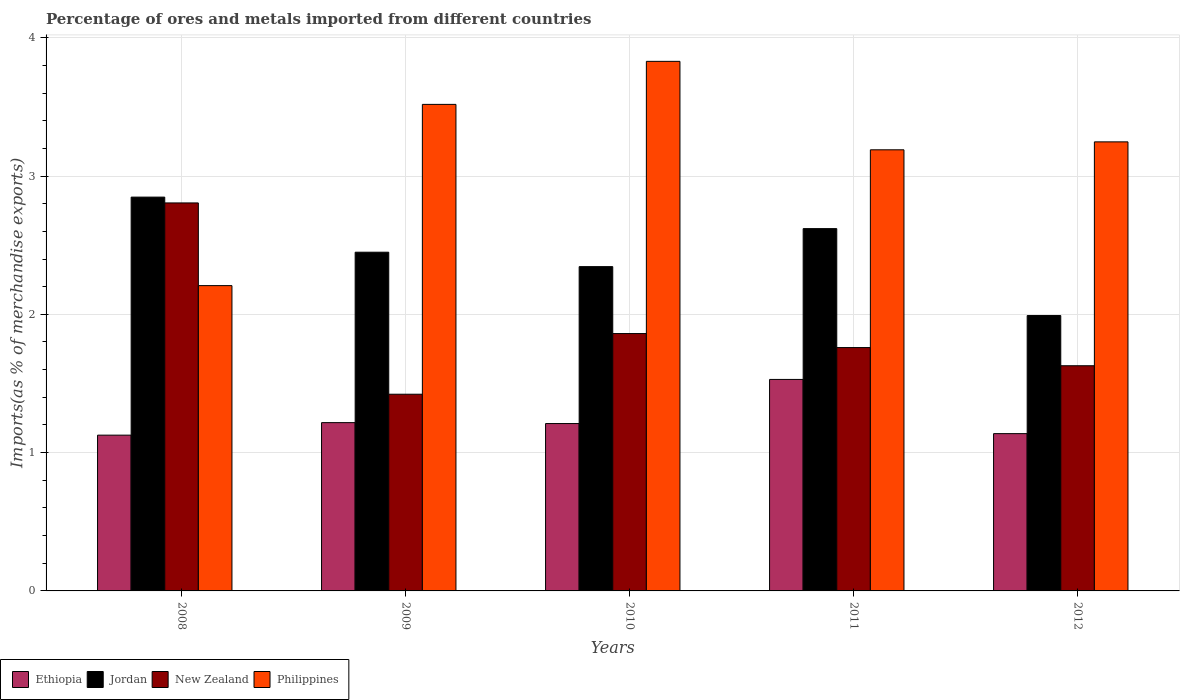How many groups of bars are there?
Ensure brevity in your answer.  5. Are the number of bars on each tick of the X-axis equal?
Your answer should be very brief. Yes. What is the percentage of imports to different countries in Ethiopia in 2012?
Ensure brevity in your answer.  1.14. Across all years, what is the maximum percentage of imports to different countries in Ethiopia?
Make the answer very short. 1.53. Across all years, what is the minimum percentage of imports to different countries in Jordan?
Offer a very short reply. 1.99. In which year was the percentage of imports to different countries in Philippines maximum?
Provide a succinct answer. 2010. In which year was the percentage of imports to different countries in Jordan minimum?
Offer a very short reply. 2012. What is the total percentage of imports to different countries in Philippines in the graph?
Provide a short and direct response. 15.99. What is the difference between the percentage of imports to different countries in Jordan in 2011 and that in 2012?
Offer a very short reply. 0.63. What is the difference between the percentage of imports to different countries in Jordan in 2011 and the percentage of imports to different countries in Philippines in 2010?
Keep it short and to the point. -1.21. What is the average percentage of imports to different countries in Ethiopia per year?
Your answer should be very brief. 1.24. In the year 2010, what is the difference between the percentage of imports to different countries in Jordan and percentage of imports to different countries in Philippines?
Ensure brevity in your answer.  -1.48. In how many years, is the percentage of imports to different countries in New Zealand greater than 3 %?
Ensure brevity in your answer.  0. What is the ratio of the percentage of imports to different countries in New Zealand in 2011 to that in 2012?
Ensure brevity in your answer.  1.08. What is the difference between the highest and the second highest percentage of imports to different countries in New Zealand?
Provide a succinct answer. 0.94. What is the difference between the highest and the lowest percentage of imports to different countries in New Zealand?
Your response must be concise. 1.38. In how many years, is the percentage of imports to different countries in Philippines greater than the average percentage of imports to different countries in Philippines taken over all years?
Keep it short and to the point. 3. Is it the case that in every year, the sum of the percentage of imports to different countries in Jordan and percentage of imports to different countries in Ethiopia is greater than the sum of percentage of imports to different countries in Philippines and percentage of imports to different countries in New Zealand?
Your answer should be compact. No. What does the 2nd bar from the left in 2010 represents?
Keep it short and to the point. Jordan. What does the 1st bar from the right in 2009 represents?
Provide a short and direct response. Philippines. How many bars are there?
Your answer should be very brief. 20. Are all the bars in the graph horizontal?
Your response must be concise. No. How many years are there in the graph?
Provide a succinct answer. 5. Does the graph contain any zero values?
Make the answer very short. No. Where does the legend appear in the graph?
Your answer should be very brief. Bottom left. How many legend labels are there?
Your answer should be compact. 4. How are the legend labels stacked?
Offer a terse response. Horizontal. What is the title of the graph?
Offer a terse response. Percentage of ores and metals imported from different countries. Does "Suriname" appear as one of the legend labels in the graph?
Provide a succinct answer. No. What is the label or title of the Y-axis?
Your response must be concise. Imports(as % of merchandise exports). What is the Imports(as % of merchandise exports) of Ethiopia in 2008?
Make the answer very short. 1.13. What is the Imports(as % of merchandise exports) of Jordan in 2008?
Ensure brevity in your answer.  2.85. What is the Imports(as % of merchandise exports) in New Zealand in 2008?
Your answer should be very brief. 2.81. What is the Imports(as % of merchandise exports) in Philippines in 2008?
Your response must be concise. 2.21. What is the Imports(as % of merchandise exports) in Ethiopia in 2009?
Give a very brief answer. 1.22. What is the Imports(as % of merchandise exports) of Jordan in 2009?
Your answer should be compact. 2.45. What is the Imports(as % of merchandise exports) of New Zealand in 2009?
Provide a short and direct response. 1.42. What is the Imports(as % of merchandise exports) of Philippines in 2009?
Give a very brief answer. 3.52. What is the Imports(as % of merchandise exports) in Ethiopia in 2010?
Make the answer very short. 1.21. What is the Imports(as % of merchandise exports) of Jordan in 2010?
Keep it short and to the point. 2.34. What is the Imports(as % of merchandise exports) of New Zealand in 2010?
Ensure brevity in your answer.  1.86. What is the Imports(as % of merchandise exports) of Philippines in 2010?
Your response must be concise. 3.83. What is the Imports(as % of merchandise exports) in Ethiopia in 2011?
Provide a succinct answer. 1.53. What is the Imports(as % of merchandise exports) in Jordan in 2011?
Keep it short and to the point. 2.62. What is the Imports(as % of merchandise exports) of New Zealand in 2011?
Offer a very short reply. 1.76. What is the Imports(as % of merchandise exports) in Philippines in 2011?
Provide a succinct answer. 3.19. What is the Imports(as % of merchandise exports) of Ethiopia in 2012?
Your answer should be compact. 1.14. What is the Imports(as % of merchandise exports) in Jordan in 2012?
Your response must be concise. 1.99. What is the Imports(as % of merchandise exports) of New Zealand in 2012?
Give a very brief answer. 1.63. What is the Imports(as % of merchandise exports) of Philippines in 2012?
Offer a terse response. 3.25. Across all years, what is the maximum Imports(as % of merchandise exports) of Ethiopia?
Offer a terse response. 1.53. Across all years, what is the maximum Imports(as % of merchandise exports) of Jordan?
Your answer should be compact. 2.85. Across all years, what is the maximum Imports(as % of merchandise exports) of New Zealand?
Your answer should be very brief. 2.81. Across all years, what is the maximum Imports(as % of merchandise exports) of Philippines?
Ensure brevity in your answer.  3.83. Across all years, what is the minimum Imports(as % of merchandise exports) in Ethiopia?
Give a very brief answer. 1.13. Across all years, what is the minimum Imports(as % of merchandise exports) in Jordan?
Your answer should be very brief. 1.99. Across all years, what is the minimum Imports(as % of merchandise exports) in New Zealand?
Give a very brief answer. 1.42. Across all years, what is the minimum Imports(as % of merchandise exports) in Philippines?
Ensure brevity in your answer.  2.21. What is the total Imports(as % of merchandise exports) in Ethiopia in the graph?
Provide a short and direct response. 6.22. What is the total Imports(as % of merchandise exports) in Jordan in the graph?
Offer a terse response. 12.25. What is the total Imports(as % of merchandise exports) in New Zealand in the graph?
Offer a terse response. 9.48. What is the total Imports(as % of merchandise exports) in Philippines in the graph?
Your answer should be compact. 15.99. What is the difference between the Imports(as % of merchandise exports) of Ethiopia in 2008 and that in 2009?
Keep it short and to the point. -0.09. What is the difference between the Imports(as % of merchandise exports) in Jordan in 2008 and that in 2009?
Your response must be concise. 0.4. What is the difference between the Imports(as % of merchandise exports) in New Zealand in 2008 and that in 2009?
Provide a short and direct response. 1.38. What is the difference between the Imports(as % of merchandise exports) of Philippines in 2008 and that in 2009?
Your answer should be very brief. -1.31. What is the difference between the Imports(as % of merchandise exports) in Ethiopia in 2008 and that in 2010?
Your response must be concise. -0.08. What is the difference between the Imports(as % of merchandise exports) of Jordan in 2008 and that in 2010?
Ensure brevity in your answer.  0.5. What is the difference between the Imports(as % of merchandise exports) of New Zealand in 2008 and that in 2010?
Keep it short and to the point. 0.94. What is the difference between the Imports(as % of merchandise exports) of Philippines in 2008 and that in 2010?
Provide a short and direct response. -1.62. What is the difference between the Imports(as % of merchandise exports) of Ethiopia in 2008 and that in 2011?
Provide a short and direct response. -0.4. What is the difference between the Imports(as % of merchandise exports) of Jordan in 2008 and that in 2011?
Your response must be concise. 0.23. What is the difference between the Imports(as % of merchandise exports) of New Zealand in 2008 and that in 2011?
Offer a terse response. 1.05. What is the difference between the Imports(as % of merchandise exports) of Philippines in 2008 and that in 2011?
Make the answer very short. -0.98. What is the difference between the Imports(as % of merchandise exports) in Ethiopia in 2008 and that in 2012?
Your answer should be compact. -0.01. What is the difference between the Imports(as % of merchandise exports) of Jordan in 2008 and that in 2012?
Your answer should be very brief. 0.86. What is the difference between the Imports(as % of merchandise exports) in New Zealand in 2008 and that in 2012?
Your response must be concise. 1.18. What is the difference between the Imports(as % of merchandise exports) of Philippines in 2008 and that in 2012?
Your answer should be compact. -1.04. What is the difference between the Imports(as % of merchandise exports) in Ethiopia in 2009 and that in 2010?
Ensure brevity in your answer.  0.01. What is the difference between the Imports(as % of merchandise exports) of Jordan in 2009 and that in 2010?
Ensure brevity in your answer.  0.1. What is the difference between the Imports(as % of merchandise exports) in New Zealand in 2009 and that in 2010?
Provide a succinct answer. -0.44. What is the difference between the Imports(as % of merchandise exports) of Philippines in 2009 and that in 2010?
Your answer should be very brief. -0.31. What is the difference between the Imports(as % of merchandise exports) of Ethiopia in 2009 and that in 2011?
Your answer should be compact. -0.31. What is the difference between the Imports(as % of merchandise exports) in Jordan in 2009 and that in 2011?
Your answer should be compact. -0.17. What is the difference between the Imports(as % of merchandise exports) in New Zealand in 2009 and that in 2011?
Your answer should be very brief. -0.34. What is the difference between the Imports(as % of merchandise exports) of Philippines in 2009 and that in 2011?
Provide a succinct answer. 0.33. What is the difference between the Imports(as % of merchandise exports) in Ethiopia in 2009 and that in 2012?
Ensure brevity in your answer.  0.08. What is the difference between the Imports(as % of merchandise exports) of Jordan in 2009 and that in 2012?
Make the answer very short. 0.46. What is the difference between the Imports(as % of merchandise exports) in New Zealand in 2009 and that in 2012?
Ensure brevity in your answer.  -0.21. What is the difference between the Imports(as % of merchandise exports) in Philippines in 2009 and that in 2012?
Ensure brevity in your answer.  0.27. What is the difference between the Imports(as % of merchandise exports) of Ethiopia in 2010 and that in 2011?
Your answer should be compact. -0.32. What is the difference between the Imports(as % of merchandise exports) in Jordan in 2010 and that in 2011?
Provide a succinct answer. -0.27. What is the difference between the Imports(as % of merchandise exports) of New Zealand in 2010 and that in 2011?
Your answer should be compact. 0.1. What is the difference between the Imports(as % of merchandise exports) in Philippines in 2010 and that in 2011?
Provide a short and direct response. 0.64. What is the difference between the Imports(as % of merchandise exports) in Ethiopia in 2010 and that in 2012?
Give a very brief answer. 0.07. What is the difference between the Imports(as % of merchandise exports) in Jordan in 2010 and that in 2012?
Provide a succinct answer. 0.35. What is the difference between the Imports(as % of merchandise exports) in New Zealand in 2010 and that in 2012?
Your answer should be compact. 0.23. What is the difference between the Imports(as % of merchandise exports) in Philippines in 2010 and that in 2012?
Provide a short and direct response. 0.58. What is the difference between the Imports(as % of merchandise exports) of Ethiopia in 2011 and that in 2012?
Provide a short and direct response. 0.39. What is the difference between the Imports(as % of merchandise exports) in Jordan in 2011 and that in 2012?
Offer a very short reply. 0.63. What is the difference between the Imports(as % of merchandise exports) in New Zealand in 2011 and that in 2012?
Give a very brief answer. 0.13. What is the difference between the Imports(as % of merchandise exports) of Philippines in 2011 and that in 2012?
Provide a succinct answer. -0.06. What is the difference between the Imports(as % of merchandise exports) of Ethiopia in 2008 and the Imports(as % of merchandise exports) of Jordan in 2009?
Provide a succinct answer. -1.32. What is the difference between the Imports(as % of merchandise exports) of Ethiopia in 2008 and the Imports(as % of merchandise exports) of New Zealand in 2009?
Your response must be concise. -0.3. What is the difference between the Imports(as % of merchandise exports) of Ethiopia in 2008 and the Imports(as % of merchandise exports) of Philippines in 2009?
Offer a very short reply. -2.39. What is the difference between the Imports(as % of merchandise exports) of Jordan in 2008 and the Imports(as % of merchandise exports) of New Zealand in 2009?
Provide a succinct answer. 1.43. What is the difference between the Imports(as % of merchandise exports) of Jordan in 2008 and the Imports(as % of merchandise exports) of Philippines in 2009?
Provide a succinct answer. -0.67. What is the difference between the Imports(as % of merchandise exports) of New Zealand in 2008 and the Imports(as % of merchandise exports) of Philippines in 2009?
Offer a very short reply. -0.71. What is the difference between the Imports(as % of merchandise exports) of Ethiopia in 2008 and the Imports(as % of merchandise exports) of Jordan in 2010?
Give a very brief answer. -1.22. What is the difference between the Imports(as % of merchandise exports) in Ethiopia in 2008 and the Imports(as % of merchandise exports) in New Zealand in 2010?
Give a very brief answer. -0.73. What is the difference between the Imports(as % of merchandise exports) of Ethiopia in 2008 and the Imports(as % of merchandise exports) of Philippines in 2010?
Your answer should be very brief. -2.7. What is the difference between the Imports(as % of merchandise exports) of Jordan in 2008 and the Imports(as % of merchandise exports) of New Zealand in 2010?
Keep it short and to the point. 0.99. What is the difference between the Imports(as % of merchandise exports) of Jordan in 2008 and the Imports(as % of merchandise exports) of Philippines in 2010?
Your answer should be compact. -0.98. What is the difference between the Imports(as % of merchandise exports) of New Zealand in 2008 and the Imports(as % of merchandise exports) of Philippines in 2010?
Ensure brevity in your answer.  -1.02. What is the difference between the Imports(as % of merchandise exports) in Ethiopia in 2008 and the Imports(as % of merchandise exports) in Jordan in 2011?
Give a very brief answer. -1.49. What is the difference between the Imports(as % of merchandise exports) of Ethiopia in 2008 and the Imports(as % of merchandise exports) of New Zealand in 2011?
Make the answer very short. -0.63. What is the difference between the Imports(as % of merchandise exports) in Ethiopia in 2008 and the Imports(as % of merchandise exports) in Philippines in 2011?
Give a very brief answer. -2.06. What is the difference between the Imports(as % of merchandise exports) in Jordan in 2008 and the Imports(as % of merchandise exports) in New Zealand in 2011?
Offer a very short reply. 1.09. What is the difference between the Imports(as % of merchandise exports) in Jordan in 2008 and the Imports(as % of merchandise exports) in Philippines in 2011?
Keep it short and to the point. -0.34. What is the difference between the Imports(as % of merchandise exports) of New Zealand in 2008 and the Imports(as % of merchandise exports) of Philippines in 2011?
Give a very brief answer. -0.38. What is the difference between the Imports(as % of merchandise exports) in Ethiopia in 2008 and the Imports(as % of merchandise exports) in Jordan in 2012?
Your answer should be very brief. -0.86. What is the difference between the Imports(as % of merchandise exports) in Ethiopia in 2008 and the Imports(as % of merchandise exports) in New Zealand in 2012?
Give a very brief answer. -0.5. What is the difference between the Imports(as % of merchandise exports) of Ethiopia in 2008 and the Imports(as % of merchandise exports) of Philippines in 2012?
Your response must be concise. -2.12. What is the difference between the Imports(as % of merchandise exports) of Jordan in 2008 and the Imports(as % of merchandise exports) of New Zealand in 2012?
Ensure brevity in your answer.  1.22. What is the difference between the Imports(as % of merchandise exports) in Jordan in 2008 and the Imports(as % of merchandise exports) in Philippines in 2012?
Provide a short and direct response. -0.4. What is the difference between the Imports(as % of merchandise exports) of New Zealand in 2008 and the Imports(as % of merchandise exports) of Philippines in 2012?
Provide a short and direct response. -0.44. What is the difference between the Imports(as % of merchandise exports) of Ethiopia in 2009 and the Imports(as % of merchandise exports) of Jordan in 2010?
Make the answer very short. -1.13. What is the difference between the Imports(as % of merchandise exports) in Ethiopia in 2009 and the Imports(as % of merchandise exports) in New Zealand in 2010?
Provide a short and direct response. -0.64. What is the difference between the Imports(as % of merchandise exports) in Ethiopia in 2009 and the Imports(as % of merchandise exports) in Philippines in 2010?
Offer a very short reply. -2.61. What is the difference between the Imports(as % of merchandise exports) in Jordan in 2009 and the Imports(as % of merchandise exports) in New Zealand in 2010?
Your answer should be very brief. 0.59. What is the difference between the Imports(as % of merchandise exports) in Jordan in 2009 and the Imports(as % of merchandise exports) in Philippines in 2010?
Make the answer very short. -1.38. What is the difference between the Imports(as % of merchandise exports) of New Zealand in 2009 and the Imports(as % of merchandise exports) of Philippines in 2010?
Provide a short and direct response. -2.41. What is the difference between the Imports(as % of merchandise exports) in Ethiopia in 2009 and the Imports(as % of merchandise exports) in Jordan in 2011?
Make the answer very short. -1.4. What is the difference between the Imports(as % of merchandise exports) of Ethiopia in 2009 and the Imports(as % of merchandise exports) of New Zealand in 2011?
Give a very brief answer. -0.54. What is the difference between the Imports(as % of merchandise exports) in Ethiopia in 2009 and the Imports(as % of merchandise exports) in Philippines in 2011?
Keep it short and to the point. -1.97. What is the difference between the Imports(as % of merchandise exports) in Jordan in 2009 and the Imports(as % of merchandise exports) in New Zealand in 2011?
Ensure brevity in your answer.  0.69. What is the difference between the Imports(as % of merchandise exports) in Jordan in 2009 and the Imports(as % of merchandise exports) in Philippines in 2011?
Your answer should be compact. -0.74. What is the difference between the Imports(as % of merchandise exports) in New Zealand in 2009 and the Imports(as % of merchandise exports) in Philippines in 2011?
Your response must be concise. -1.77. What is the difference between the Imports(as % of merchandise exports) of Ethiopia in 2009 and the Imports(as % of merchandise exports) of Jordan in 2012?
Keep it short and to the point. -0.77. What is the difference between the Imports(as % of merchandise exports) in Ethiopia in 2009 and the Imports(as % of merchandise exports) in New Zealand in 2012?
Offer a terse response. -0.41. What is the difference between the Imports(as % of merchandise exports) in Ethiopia in 2009 and the Imports(as % of merchandise exports) in Philippines in 2012?
Your response must be concise. -2.03. What is the difference between the Imports(as % of merchandise exports) in Jordan in 2009 and the Imports(as % of merchandise exports) in New Zealand in 2012?
Give a very brief answer. 0.82. What is the difference between the Imports(as % of merchandise exports) of Jordan in 2009 and the Imports(as % of merchandise exports) of Philippines in 2012?
Make the answer very short. -0.8. What is the difference between the Imports(as % of merchandise exports) of New Zealand in 2009 and the Imports(as % of merchandise exports) of Philippines in 2012?
Offer a terse response. -1.82. What is the difference between the Imports(as % of merchandise exports) in Ethiopia in 2010 and the Imports(as % of merchandise exports) in Jordan in 2011?
Provide a succinct answer. -1.41. What is the difference between the Imports(as % of merchandise exports) of Ethiopia in 2010 and the Imports(as % of merchandise exports) of New Zealand in 2011?
Make the answer very short. -0.55. What is the difference between the Imports(as % of merchandise exports) of Ethiopia in 2010 and the Imports(as % of merchandise exports) of Philippines in 2011?
Ensure brevity in your answer.  -1.98. What is the difference between the Imports(as % of merchandise exports) of Jordan in 2010 and the Imports(as % of merchandise exports) of New Zealand in 2011?
Your response must be concise. 0.59. What is the difference between the Imports(as % of merchandise exports) of Jordan in 2010 and the Imports(as % of merchandise exports) of Philippines in 2011?
Give a very brief answer. -0.84. What is the difference between the Imports(as % of merchandise exports) of New Zealand in 2010 and the Imports(as % of merchandise exports) of Philippines in 2011?
Make the answer very short. -1.33. What is the difference between the Imports(as % of merchandise exports) in Ethiopia in 2010 and the Imports(as % of merchandise exports) in Jordan in 2012?
Provide a succinct answer. -0.78. What is the difference between the Imports(as % of merchandise exports) in Ethiopia in 2010 and the Imports(as % of merchandise exports) in New Zealand in 2012?
Provide a short and direct response. -0.42. What is the difference between the Imports(as % of merchandise exports) in Ethiopia in 2010 and the Imports(as % of merchandise exports) in Philippines in 2012?
Make the answer very short. -2.04. What is the difference between the Imports(as % of merchandise exports) in Jordan in 2010 and the Imports(as % of merchandise exports) in New Zealand in 2012?
Keep it short and to the point. 0.72. What is the difference between the Imports(as % of merchandise exports) of Jordan in 2010 and the Imports(as % of merchandise exports) of Philippines in 2012?
Offer a terse response. -0.9. What is the difference between the Imports(as % of merchandise exports) in New Zealand in 2010 and the Imports(as % of merchandise exports) in Philippines in 2012?
Keep it short and to the point. -1.39. What is the difference between the Imports(as % of merchandise exports) of Ethiopia in 2011 and the Imports(as % of merchandise exports) of Jordan in 2012?
Provide a short and direct response. -0.46. What is the difference between the Imports(as % of merchandise exports) in Ethiopia in 2011 and the Imports(as % of merchandise exports) in New Zealand in 2012?
Make the answer very short. -0.1. What is the difference between the Imports(as % of merchandise exports) of Ethiopia in 2011 and the Imports(as % of merchandise exports) of Philippines in 2012?
Make the answer very short. -1.72. What is the difference between the Imports(as % of merchandise exports) of Jordan in 2011 and the Imports(as % of merchandise exports) of New Zealand in 2012?
Ensure brevity in your answer.  0.99. What is the difference between the Imports(as % of merchandise exports) of Jordan in 2011 and the Imports(as % of merchandise exports) of Philippines in 2012?
Give a very brief answer. -0.63. What is the difference between the Imports(as % of merchandise exports) of New Zealand in 2011 and the Imports(as % of merchandise exports) of Philippines in 2012?
Your answer should be compact. -1.49. What is the average Imports(as % of merchandise exports) in Ethiopia per year?
Your answer should be very brief. 1.24. What is the average Imports(as % of merchandise exports) of Jordan per year?
Give a very brief answer. 2.45. What is the average Imports(as % of merchandise exports) in New Zealand per year?
Offer a very short reply. 1.9. What is the average Imports(as % of merchandise exports) in Philippines per year?
Offer a terse response. 3.2. In the year 2008, what is the difference between the Imports(as % of merchandise exports) in Ethiopia and Imports(as % of merchandise exports) in Jordan?
Keep it short and to the point. -1.72. In the year 2008, what is the difference between the Imports(as % of merchandise exports) in Ethiopia and Imports(as % of merchandise exports) in New Zealand?
Your response must be concise. -1.68. In the year 2008, what is the difference between the Imports(as % of merchandise exports) of Ethiopia and Imports(as % of merchandise exports) of Philippines?
Your response must be concise. -1.08. In the year 2008, what is the difference between the Imports(as % of merchandise exports) of Jordan and Imports(as % of merchandise exports) of New Zealand?
Provide a short and direct response. 0.04. In the year 2008, what is the difference between the Imports(as % of merchandise exports) of Jordan and Imports(as % of merchandise exports) of Philippines?
Offer a terse response. 0.64. In the year 2008, what is the difference between the Imports(as % of merchandise exports) in New Zealand and Imports(as % of merchandise exports) in Philippines?
Your answer should be very brief. 0.6. In the year 2009, what is the difference between the Imports(as % of merchandise exports) of Ethiopia and Imports(as % of merchandise exports) of Jordan?
Keep it short and to the point. -1.23. In the year 2009, what is the difference between the Imports(as % of merchandise exports) of Ethiopia and Imports(as % of merchandise exports) of New Zealand?
Offer a terse response. -0.21. In the year 2009, what is the difference between the Imports(as % of merchandise exports) of Ethiopia and Imports(as % of merchandise exports) of Philippines?
Give a very brief answer. -2.3. In the year 2009, what is the difference between the Imports(as % of merchandise exports) in Jordan and Imports(as % of merchandise exports) in New Zealand?
Make the answer very short. 1.03. In the year 2009, what is the difference between the Imports(as % of merchandise exports) of Jordan and Imports(as % of merchandise exports) of Philippines?
Offer a terse response. -1.07. In the year 2009, what is the difference between the Imports(as % of merchandise exports) of New Zealand and Imports(as % of merchandise exports) of Philippines?
Ensure brevity in your answer.  -2.1. In the year 2010, what is the difference between the Imports(as % of merchandise exports) in Ethiopia and Imports(as % of merchandise exports) in Jordan?
Offer a terse response. -1.13. In the year 2010, what is the difference between the Imports(as % of merchandise exports) in Ethiopia and Imports(as % of merchandise exports) in New Zealand?
Give a very brief answer. -0.65. In the year 2010, what is the difference between the Imports(as % of merchandise exports) in Ethiopia and Imports(as % of merchandise exports) in Philippines?
Give a very brief answer. -2.62. In the year 2010, what is the difference between the Imports(as % of merchandise exports) in Jordan and Imports(as % of merchandise exports) in New Zealand?
Provide a succinct answer. 0.48. In the year 2010, what is the difference between the Imports(as % of merchandise exports) in Jordan and Imports(as % of merchandise exports) in Philippines?
Your answer should be compact. -1.48. In the year 2010, what is the difference between the Imports(as % of merchandise exports) of New Zealand and Imports(as % of merchandise exports) of Philippines?
Give a very brief answer. -1.97. In the year 2011, what is the difference between the Imports(as % of merchandise exports) in Ethiopia and Imports(as % of merchandise exports) in Jordan?
Your answer should be very brief. -1.09. In the year 2011, what is the difference between the Imports(as % of merchandise exports) in Ethiopia and Imports(as % of merchandise exports) in New Zealand?
Your answer should be very brief. -0.23. In the year 2011, what is the difference between the Imports(as % of merchandise exports) of Ethiopia and Imports(as % of merchandise exports) of Philippines?
Your answer should be compact. -1.66. In the year 2011, what is the difference between the Imports(as % of merchandise exports) of Jordan and Imports(as % of merchandise exports) of New Zealand?
Your answer should be very brief. 0.86. In the year 2011, what is the difference between the Imports(as % of merchandise exports) of Jordan and Imports(as % of merchandise exports) of Philippines?
Offer a very short reply. -0.57. In the year 2011, what is the difference between the Imports(as % of merchandise exports) in New Zealand and Imports(as % of merchandise exports) in Philippines?
Your answer should be very brief. -1.43. In the year 2012, what is the difference between the Imports(as % of merchandise exports) in Ethiopia and Imports(as % of merchandise exports) in Jordan?
Make the answer very short. -0.85. In the year 2012, what is the difference between the Imports(as % of merchandise exports) of Ethiopia and Imports(as % of merchandise exports) of New Zealand?
Provide a short and direct response. -0.49. In the year 2012, what is the difference between the Imports(as % of merchandise exports) of Ethiopia and Imports(as % of merchandise exports) of Philippines?
Your response must be concise. -2.11. In the year 2012, what is the difference between the Imports(as % of merchandise exports) of Jordan and Imports(as % of merchandise exports) of New Zealand?
Provide a short and direct response. 0.36. In the year 2012, what is the difference between the Imports(as % of merchandise exports) in Jordan and Imports(as % of merchandise exports) in Philippines?
Provide a succinct answer. -1.26. In the year 2012, what is the difference between the Imports(as % of merchandise exports) of New Zealand and Imports(as % of merchandise exports) of Philippines?
Your response must be concise. -1.62. What is the ratio of the Imports(as % of merchandise exports) of Ethiopia in 2008 to that in 2009?
Give a very brief answer. 0.93. What is the ratio of the Imports(as % of merchandise exports) of Jordan in 2008 to that in 2009?
Provide a succinct answer. 1.16. What is the ratio of the Imports(as % of merchandise exports) of New Zealand in 2008 to that in 2009?
Offer a very short reply. 1.97. What is the ratio of the Imports(as % of merchandise exports) in Philippines in 2008 to that in 2009?
Offer a very short reply. 0.63. What is the ratio of the Imports(as % of merchandise exports) of Ethiopia in 2008 to that in 2010?
Offer a very short reply. 0.93. What is the ratio of the Imports(as % of merchandise exports) in Jordan in 2008 to that in 2010?
Provide a short and direct response. 1.21. What is the ratio of the Imports(as % of merchandise exports) of New Zealand in 2008 to that in 2010?
Your answer should be very brief. 1.51. What is the ratio of the Imports(as % of merchandise exports) of Philippines in 2008 to that in 2010?
Keep it short and to the point. 0.58. What is the ratio of the Imports(as % of merchandise exports) in Ethiopia in 2008 to that in 2011?
Offer a terse response. 0.74. What is the ratio of the Imports(as % of merchandise exports) of Jordan in 2008 to that in 2011?
Give a very brief answer. 1.09. What is the ratio of the Imports(as % of merchandise exports) in New Zealand in 2008 to that in 2011?
Your response must be concise. 1.59. What is the ratio of the Imports(as % of merchandise exports) in Philippines in 2008 to that in 2011?
Your answer should be very brief. 0.69. What is the ratio of the Imports(as % of merchandise exports) in Ethiopia in 2008 to that in 2012?
Ensure brevity in your answer.  0.99. What is the ratio of the Imports(as % of merchandise exports) of Jordan in 2008 to that in 2012?
Keep it short and to the point. 1.43. What is the ratio of the Imports(as % of merchandise exports) in New Zealand in 2008 to that in 2012?
Offer a very short reply. 1.72. What is the ratio of the Imports(as % of merchandise exports) of Philippines in 2008 to that in 2012?
Offer a terse response. 0.68. What is the ratio of the Imports(as % of merchandise exports) of Ethiopia in 2009 to that in 2010?
Your answer should be compact. 1.01. What is the ratio of the Imports(as % of merchandise exports) of Jordan in 2009 to that in 2010?
Ensure brevity in your answer.  1.04. What is the ratio of the Imports(as % of merchandise exports) of New Zealand in 2009 to that in 2010?
Offer a terse response. 0.76. What is the ratio of the Imports(as % of merchandise exports) in Philippines in 2009 to that in 2010?
Make the answer very short. 0.92. What is the ratio of the Imports(as % of merchandise exports) in Ethiopia in 2009 to that in 2011?
Your response must be concise. 0.8. What is the ratio of the Imports(as % of merchandise exports) in Jordan in 2009 to that in 2011?
Offer a terse response. 0.93. What is the ratio of the Imports(as % of merchandise exports) of New Zealand in 2009 to that in 2011?
Your answer should be compact. 0.81. What is the ratio of the Imports(as % of merchandise exports) of Philippines in 2009 to that in 2011?
Your answer should be compact. 1.1. What is the ratio of the Imports(as % of merchandise exports) of Ethiopia in 2009 to that in 2012?
Your answer should be very brief. 1.07. What is the ratio of the Imports(as % of merchandise exports) in Jordan in 2009 to that in 2012?
Give a very brief answer. 1.23. What is the ratio of the Imports(as % of merchandise exports) of New Zealand in 2009 to that in 2012?
Your response must be concise. 0.87. What is the ratio of the Imports(as % of merchandise exports) of Philippines in 2009 to that in 2012?
Your response must be concise. 1.08. What is the ratio of the Imports(as % of merchandise exports) of Ethiopia in 2010 to that in 2011?
Ensure brevity in your answer.  0.79. What is the ratio of the Imports(as % of merchandise exports) in Jordan in 2010 to that in 2011?
Your answer should be compact. 0.9. What is the ratio of the Imports(as % of merchandise exports) of New Zealand in 2010 to that in 2011?
Provide a succinct answer. 1.06. What is the ratio of the Imports(as % of merchandise exports) of Philippines in 2010 to that in 2011?
Your answer should be compact. 1.2. What is the ratio of the Imports(as % of merchandise exports) in Ethiopia in 2010 to that in 2012?
Offer a very short reply. 1.06. What is the ratio of the Imports(as % of merchandise exports) in Jordan in 2010 to that in 2012?
Your answer should be very brief. 1.18. What is the ratio of the Imports(as % of merchandise exports) in New Zealand in 2010 to that in 2012?
Offer a very short reply. 1.14. What is the ratio of the Imports(as % of merchandise exports) in Philippines in 2010 to that in 2012?
Provide a succinct answer. 1.18. What is the ratio of the Imports(as % of merchandise exports) of Ethiopia in 2011 to that in 2012?
Your answer should be very brief. 1.34. What is the ratio of the Imports(as % of merchandise exports) in Jordan in 2011 to that in 2012?
Your answer should be very brief. 1.32. What is the ratio of the Imports(as % of merchandise exports) of New Zealand in 2011 to that in 2012?
Offer a terse response. 1.08. What is the ratio of the Imports(as % of merchandise exports) in Philippines in 2011 to that in 2012?
Your answer should be very brief. 0.98. What is the difference between the highest and the second highest Imports(as % of merchandise exports) of Ethiopia?
Provide a short and direct response. 0.31. What is the difference between the highest and the second highest Imports(as % of merchandise exports) of Jordan?
Offer a terse response. 0.23. What is the difference between the highest and the second highest Imports(as % of merchandise exports) of New Zealand?
Ensure brevity in your answer.  0.94. What is the difference between the highest and the second highest Imports(as % of merchandise exports) in Philippines?
Keep it short and to the point. 0.31. What is the difference between the highest and the lowest Imports(as % of merchandise exports) in Ethiopia?
Your answer should be very brief. 0.4. What is the difference between the highest and the lowest Imports(as % of merchandise exports) of Jordan?
Provide a short and direct response. 0.86. What is the difference between the highest and the lowest Imports(as % of merchandise exports) of New Zealand?
Provide a short and direct response. 1.38. What is the difference between the highest and the lowest Imports(as % of merchandise exports) of Philippines?
Ensure brevity in your answer.  1.62. 